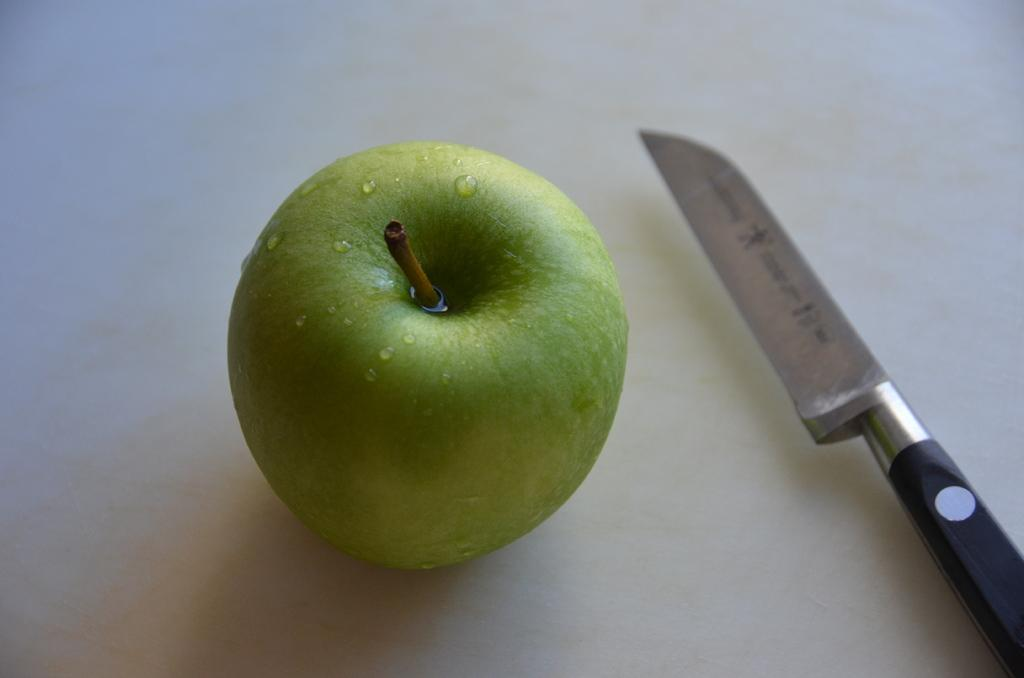What type of fruit is in the image? There is a green apple in the image. What object is present that could be used to cut the apple? There is a knife in the image. What type of sign is visible in the image? There is no sign present in the image; it only features a green apple and a knife. Can you tell me how many jellyfish are swimming in the image? There are no jellyfish present in the image. 